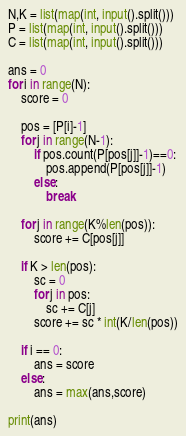<code> <loc_0><loc_0><loc_500><loc_500><_Python_>N,K = list(map(int, input().split()))
P = list(map(int, input().split()))
C = list(map(int, input().split()))

ans = 0
for i in range(N):
    score = 0
    
    pos = [P[i]-1]
    for j in range(N-1):
        if pos.count(P[pos[j]]-1)==0:
            pos.append(P[pos[j]]-1)
        else:
            break
            
    for j in range(K%len(pos)):
        score += C[pos[j]]
    
    if K > len(pos):
        sc = 0
        for j in pos:
            sc += C[j]
        score += sc * int(K/len(pos))
    
    if i == 0:
        ans = score
    else:
        ans = max(ans,score)

print(ans)</code> 